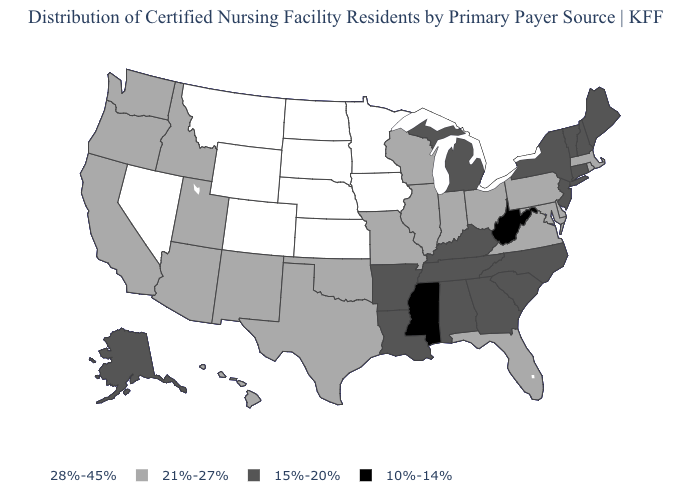Name the states that have a value in the range 21%-27%?
Write a very short answer. Arizona, California, Delaware, Florida, Hawaii, Idaho, Illinois, Indiana, Maryland, Massachusetts, Missouri, New Mexico, Ohio, Oklahoma, Oregon, Pennsylvania, Rhode Island, Texas, Utah, Virginia, Washington, Wisconsin. What is the value of Georgia?
Keep it brief. 15%-20%. What is the value of Washington?
Quick response, please. 21%-27%. What is the value of Nevada?
Short answer required. 28%-45%. What is the value of Oklahoma?
Concise answer only. 21%-27%. Among the states that border New York , which have the highest value?
Write a very short answer. Massachusetts, Pennsylvania. Name the states that have a value in the range 21%-27%?
Give a very brief answer. Arizona, California, Delaware, Florida, Hawaii, Idaho, Illinois, Indiana, Maryland, Massachusetts, Missouri, New Mexico, Ohio, Oklahoma, Oregon, Pennsylvania, Rhode Island, Texas, Utah, Virginia, Washington, Wisconsin. What is the value of South Dakota?
Answer briefly. 28%-45%. Among the states that border Wyoming , does Colorado have the highest value?
Quick response, please. Yes. Name the states that have a value in the range 21%-27%?
Keep it brief. Arizona, California, Delaware, Florida, Hawaii, Idaho, Illinois, Indiana, Maryland, Massachusetts, Missouri, New Mexico, Ohio, Oklahoma, Oregon, Pennsylvania, Rhode Island, Texas, Utah, Virginia, Washington, Wisconsin. What is the highest value in states that border Alabama?
Quick response, please. 21%-27%. Among the states that border New Hampshire , does Maine have the highest value?
Quick response, please. No. Does Maryland have a lower value than Iowa?
Short answer required. Yes. Does Alaska have the highest value in the West?
Answer briefly. No. Does Missouri have a higher value than New Jersey?
Answer briefly. Yes. 